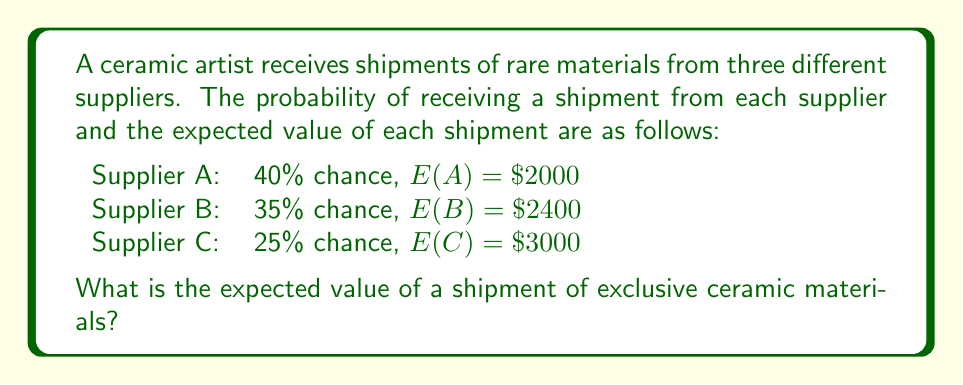Could you help me with this problem? To determine the expected value of a shipment, we need to use the law of total expectation. This involves calculating the weighted sum of the expected values from each supplier, where the weights are the probabilities of receiving a shipment from that supplier.

Let's break it down step by step:

1. For Supplier A:
   Probability = 40% = 0.4
   Expected Value = $\$2000$
   Weighted Value = $0.4 \times \$2000 = \$800$

2. For Supplier B:
   Probability = 35% = 0.35
   Expected Value = $\$2400$
   Weighted Value = $0.35 \times \$2400 = \$840$

3. For Supplier C:
   Probability = 25% = 0.25
   Expected Value = $\$3000$
   Weighted Value = $0.25 \times \$3000 = \$750$

4. The total expected value is the sum of these weighted values:

   $E(\text{shipment}) = \$800 + \$840 + \$750 = \$2390$

Therefore, the expected value of a shipment of exclusive ceramic materials is $\$2390$.
Answer: $\$2390$ 